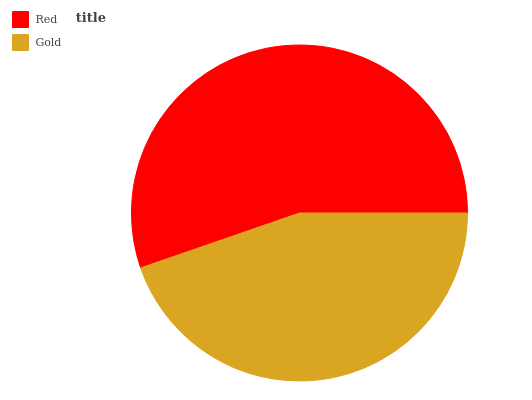Is Gold the minimum?
Answer yes or no. Yes. Is Red the maximum?
Answer yes or no. Yes. Is Gold the maximum?
Answer yes or no. No. Is Red greater than Gold?
Answer yes or no. Yes. Is Gold less than Red?
Answer yes or no. Yes. Is Gold greater than Red?
Answer yes or no. No. Is Red less than Gold?
Answer yes or no. No. Is Red the high median?
Answer yes or no. Yes. Is Gold the low median?
Answer yes or no. Yes. Is Gold the high median?
Answer yes or no. No. Is Red the low median?
Answer yes or no. No. 